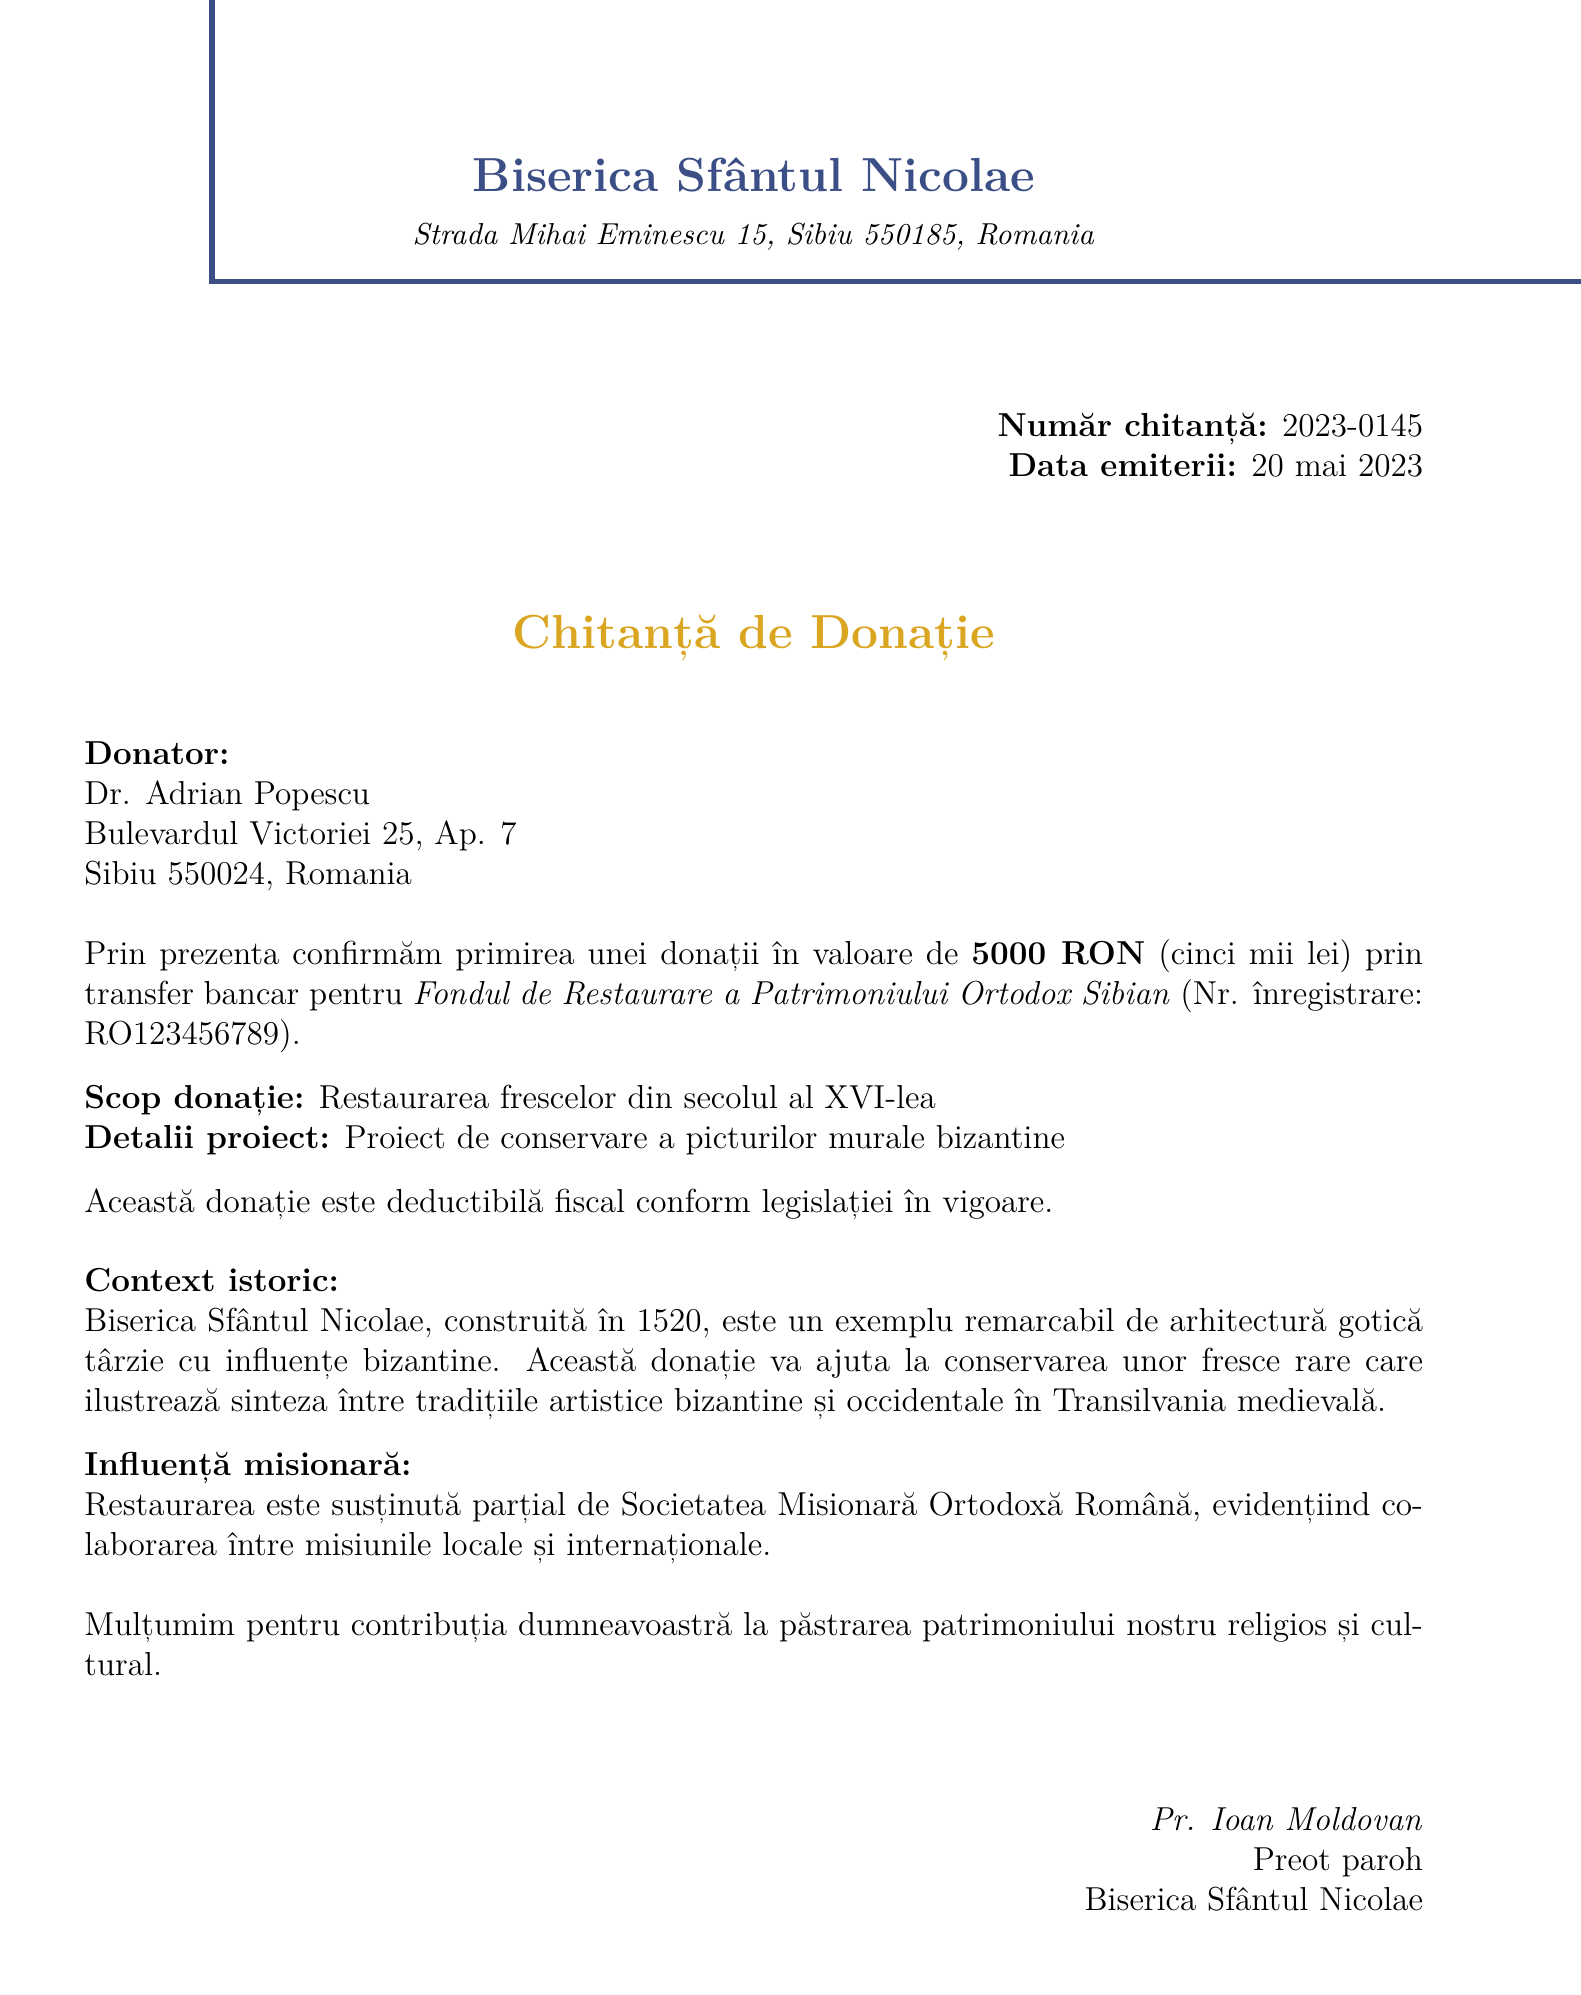What is the name of the church? The name of the church is stated at the beginning of the document as "Biserica Sfântul Nicolae."
Answer: Biserica Sfântul Nicolae What is the date of the receipt? The date of the receipt is provided in the "Data emiterii" section as "20 mai 2023."
Answer: 20 mai 2023 Who is the donor? The document lists the donor's name as "Dr. Adrian Popescu."
Answer: Dr. Adrian Popescu What was the amount donated? The amount donated is clearly stated as "5000 RON" in the donation confirmation section.
Answer: 5000 RON What is the purpose of the donation? The purpose of the donation can be found in the "Scop donație" section as "Restaurarea frescelor din secolul al XVI-lea."
Answer: Restaurarea frescelor din secolul al XVI-lea What is the registration number of the restoration fund? The registration number of the restoration fund is mentioned as "RO123456789."
Answer: RO123456789 What type of influence is mentioned in the document? The document refers to "influență misionară" indicating a missionary influence on the restoration project.
Answer: influență misionară What is the name of the church representative? The name of the church representative, as stated in the document, is "Pr. Ioan Moldovan."
Answer: Pr. Ioan Moldovan What is the historical context provided about the church? The document includes a brief history stating it was "construită în 1520" and details its architectural significance.
Answer: construită în 1520 